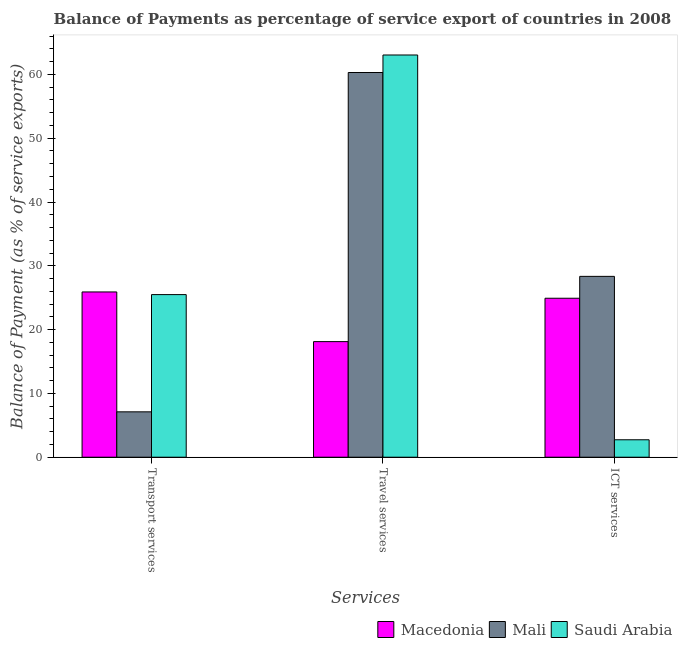How many groups of bars are there?
Offer a terse response. 3. Are the number of bars per tick equal to the number of legend labels?
Your answer should be compact. Yes. Are the number of bars on each tick of the X-axis equal?
Your response must be concise. Yes. How many bars are there on the 3rd tick from the left?
Your response must be concise. 3. How many bars are there on the 3rd tick from the right?
Offer a terse response. 3. What is the label of the 2nd group of bars from the left?
Ensure brevity in your answer.  Travel services. What is the balance of payment of travel services in Saudi Arabia?
Ensure brevity in your answer.  63.05. Across all countries, what is the maximum balance of payment of transport services?
Your answer should be very brief. 25.91. Across all countries, what is the minimum balance of payment of ict services?
Make the answer very short. 2.73. In which country was the balance of payment of transport services maximum?
Ensure brevity in your answer.  Macedonia. In which country was the balance of payment of travel services minimum?
Offer a very short reply. Macedonia. What is the total balance of payment of ict services in the graph?
Make the answer very short. 56. What is the difference between the balance of payment of transport services in Mali and that in Saudi Arabia?
Your response must be concise. -18.38. What is the difference between the balance of payment of ict services in Macedonia and the balance of payment of travel services in Mali?
Make the answer very short. -35.39. What is the average balance of payment of transport services per country?
Your answer should be very brief. 19.5. What is the difference between the balance of payment of travel services and balance of payment of ict services in Saudi Arabia?
Provide a succinct answer. 60.31. In how many countries, is the balance of payment of travel services greater than 30 %?
Your answer should be very brief. 2. What is the ratio of the balance of payment of transport services in Macedonia to that in Saudi Arabia?
Your response must be concise. 1.02. What is the difference between the highest and the second highest balance of payment of ict services?
Offer a very short reply. 3.43. What is the difference between the highest and the lowest balance of payment of ict services?
Your answer should be very brief. 25.61. In how many countries, is the balance of payment of ict services greater than the average balance of payment of ict services taken over all countries?
Provide a short and direct response. 2. What does the 2nd bar from the left in Transport services represents?
Your answer should be very brief. Mali. What does the 2nd bar from the right in Transport services represents?
Make the answer very short. Mali. Is it the case that in every country, the sum of the balance of payment of transport services and balance of payment of travel services is greater than the balance of payment of ict services?
Provide a short and direct response. Yes. How many bars are there?
Provide a short and direct response. 9. How many countries are there in the graph?
Offer a very short reply. 3. Are the values on the major ticks of Y-axis written in scientific E-notation?
Provide a succinct answer. No. Does the graph contain any zero values?
Provide a succinct answer. No. Where does the legend appear in the graph?
Offer a very short reply. Bottom right. What is the title of the graph?
Your response must be concise. Balance of Payments as percentage of service export of countries in 2008. Does "Costa Rica" appear as one of the legend labels in the graph?
Keep it short and to the point. No. What is the label or title of the X-axis?
Ensure brevity in your answer.  Services. What is the label or title of the Y-axis?
Ensure brevity in your answer.  Balance of Payment (as % of service exports). What is the Balance of Payment (as % of service exports) of Macedonia in Transport services?
Keep it short and to the point. 25.91. What is the Balance of Payment (as % of service exports) of Mali in Transport services?
Give a very brief answer. 7.11. What is the Balance of Payment (as % of service exports) in Saudi Arabia in Transport services?
Your answer should be compact. 25.49. What is the Balance of Payment (as % of service exports) in Macedonia in Travel services?
Your answer should be very brief. 18.12. What is the Balance of Payment (as % of service exports) in Mali in Travel services?
Your response must be concise. 60.3. What is the Balance of Payment (as % of service exports) in Saudi Arabia in Travel services?
Provide a succinct answer. 63.05. What is the Balance of Payment (as % of service exports) of Macedonia in ICT services?
Provide a short and direct response. 24.92. What is the Balance of Payment (as % of service exports) in Mali in ICT services?
Give a very brief answer. 28.35. What is the Balance of Payment (as % of service exports) in Saudi Arabia in ICT services?
Your answer should be compact. 2.73. Across all Services, what is the maximum Balance of Payment (as % of service exports) in Macedonia?
Your answer should be compact. 25.91. Across all Services, what is the maximum Balance of Payment (as % of service exports) of Mali?
Keep it short and to the point. 60.3. Across all Services, what is the maximum Balance of Payment (as % of service exports) in Saudi Arabia?
Your answer should be compact. 63.05. Across all Services, what is the minimum Balance of Payment (as % of service exports) of Macedonia?
Your answer should be compact. 18.12. Across all Services, what is the minimum Balance of Payment (as % of service exports) of Mali?
Offer a terse response. 7.11. Across all Services, what is the minimum Balance of Payment (as % of service exports) of Saudi Arabia?
Keep it short and to the point. 2.73. What is the total Balance of Payment (as % of service exports) in Macedonia in the graph?
Provide a short and direct response. 68.94. What is the total Balance of Payment (as % of service exports) of Mali in the graph?
Keep it short and to the point. 95.77. What is the total Balance of Payment (as % of service exports) of Saudi Arabia in the graph?
Make the answer very short. 91.27. What is the difference between the Balance of Payment (as % of service exports) in Macedonia in Transport services and that in Travel services?
Your answer should be compact. 7.78. What is the difference between the Balance of Payment (as % of service exports) of Mali in Transport services and that in Travel services?
Provide a short and direct response. -53.19. What is the difference between the Balance of Payment (as % of service exports) of Saudi Arabia in Transport services and that in Travel services?
Your response must be concise. -37.56. What is the difference between the Balance of Payment (as % of service exports) of Macedonia in Transport services and that in ICT services?
Give a very brief answer. 0.99. What is the difference between the Balance of Payment (as % of service exports) in Mali in Transport services and that in ICT services?
Your answer should be compact. -21.23. What is the difference between the Balance of Payment (as % of service exports) in Saudi Arabia in Transport services and that in ICT services?
Offer a terse response. 22.76. What is the difference between the Balance of Payment (as % of service exports) in Macedonia in Travel services and that in ICT services?
Offer a terse response. -6.8. What is the difference between the Balance of Payment (as % of service exports) in Mali in Travel services and that in ICT services?
Provide a succinct answer. 31.95. What is the difference between the Balance of Payment (as % of service exports) of Saudi Arabia in Travel services and that in ICT services?
Provide a short and direct response. 60.31. What is the difference between the Balance of Payment (as % of service exports) of Macedonia in Transport services and the Balance of Payment (as % of service exports) of Mali in Travel services?
Provide a short and direct response. -34.4. What is the difference between the Balance of Payment (as % of service exports) in Macedonia in Transport services and the Balance of Payment (as % of service exports) in Saudi Arabia in Travel services?
Your response must be concise. -37.14. What is the difference between the Balance of Payment (as % of service exports) of Mali in Transport services and the Balance of Payment (as % of service exports) of Saudi Arabia in Travel services?
Your answer should be compact. -55.94. What is the difference between the Balance of Payment (as % of service exports) in Macedonia in Transport services and the Balance of Payment (as % of service exports) in Mali in ICT services?
Keep it short and to the point. -2.44. What is the difference between the Balance of Payment (as % of service exports) of Macedonia in Transport services and the Balance of Payment (as % of service exports) of Saudi Arabia in ICT services?
Your answer should be very brief. 23.17. What is the difference between the Balance of Payment (as % of service exports) in Mali in Transport services and the Balance of Payment (as % of service exports) in Saudi Arabia in ICT services?
Your answer should be very brief. 4.38. What is the difference between the Balance of Payment (as % of service exports) of Macedonia in Travel services and the Balance of Payment (as % of service exports) of Mali in ICT services?
Offer a terse response. -10.23. What is the difference between the Balance of Payment (as % of service exports) of Macedonia in Travel services and the Balance of Payment (as % of service exports) of Saudi Arabia in ICT services?
Your answer should be very brief. 15.39. What is the difference between the Balance of Payment (as % of service exports) of Mali in Travel services and the Balance of Payment (as % of service exports) of Saudi Arabia in ICT services?
Make the answer very short. 57.57. What is the average Balance of Payment (as % of service exports) in Macedonia per Services?
Your response must be concise. 22.98. What is the average Balance of Payment (as % of service exports) in Mali per Services?
Make the answer very short. 31.92. What is the average Balance of Payment (as % of service exports) of Saudi Arabia per Services?
Make the answer very short. 30.42. What is the difference between the Balance of Payment (as % of service exports) of Macedonia and Balance of Payment (as % of service exports) of Mali in Transport services?
Ensure brevity in your answer.  18.79. What is the difference between the Balance of Payment (as % of service exports) in Macedonia and Balance of Payment (as % of service exports) in Saudi Arabia in Transport services?
Make the answer very short. 0.42. What is the difference between the Balance of Payment (as % of service exports) of Mali and Balance of Payment (as % of service exports) of Saudi Arabia in Transport services?
Ensure brevity in your answer.  -18.38. What is the difference between the Balance of Payment (as % of service exports) of Macedonia and Balance of Payment (as % of service exports) of Mali in Travel services?
Make the answer very short. -42.18. What is the difference between the Balance of Payment (as % of service exports) of Macedonia and Balance of Payment (as % of service exports) of Saudi Arabia in Travel services?
Your answer should be very brief. -44.93. What is the difference between the Balance of Payment (as % of service exports) of Mali and Balance of Payment (as % of service exports) of Saudi Arabia in Travel services?
Your answer should be compact. -2.75. What is the difference between the Balance of Payment (as % of service exports) in Macedonia and Balance of Payment (as % of service exports) in Mali in ICT services?
Offer a terse response. -3.43. What is the difference between the Balance of Payment (as % of service exports) in Macedonia and Balance of Payment (as % of service exports) in Saudi Arabia in ICT services?
Offer a terse response. 22.18. What is the difference between the Balance of Payment (as % of service exports) of Mali and Balance of Payment (as % of service exports) of Saudi Arabia in ICT services?
Keep it short and to the point. 25.61. What is the ratio of the Balance of Payment (as % of service exports) in Macedonia in Transport services to that in Travel services?
Give a very brief answer. 1.43. What is the ratio of the Balance of Payment (as % of service exports) of Mali in Transport services to that in Travel services?
Provide a succinct answer. 0.12. What is the ratio of the Balance of Payment (as % of service exports) in Saudi Arabia in Transport services to that in Travel services?
Ensure brevity in your answer.  0.4. What is the ratio of the Balance of Payment (as % of service exports) in Macedonia in Transport services to that in ICT services?
Give a very brief answer. 1.04. What is the ratio of the Balance of Payment (as % of service exports) in Mali in Transport services to that in ICT services?
Your answer should be very brief. 0.25. What is the ratio of the Balance of Payment (as % of service exports) of Saudi Arabia in Transport services to that in ICT services?
Keep it short and to the point. 9.32. What is the ratio of the Balance of Payment (as % of service exports) of Macedonia in Travel services to that in ICT services?
Offer a terse response. 0.73. What is the ratio of the Balance of Payment (as % of service exports) in Mali in Travel services to that in ICT services?
Your response must be concise. 2.13. What is the ratio of the Balance of Payment (as % of service exports) in Saudi Arabia in Travel services to that in ICT services?
Make the answer very short. 23.05. What is the difference between the highest and the second highest Balance of Payment (as % of service exports) in Macedonia?
Keep it short and to the point. 0.99. What is the difference between the highest and the second highest Balance of Payment (as % of service exports) in Mali?
Provide a short and direct response. 31.95. What is the difference between the highest and the second highest Balance of Payment (as % of service exports) of Saudi Arabia?
Offer a terse response. 37.56. What is the difference between the highest and the lowest Balance of Payment (as % of service exports) in Macedonia?
Provide a short and direct response. 7.78. What is the difference between the highest and the lowest Balance of Payment (as % of service exports) of Mali?
Make the answer very short. 53.19. What is the difference between the highest and the lowest Balance of Payment (as % of service exports) of Saudi Arabia?
Provide a short and direct response. 60.31. 